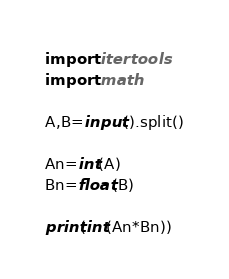Convert code to text. <code><loc_0><loc_0><loc_500><loc_500><_Python_>import itertools
import math

A,B=input().split()

An=int(A)
Bn=float(B)

print(int(An*Bn))
</code> 